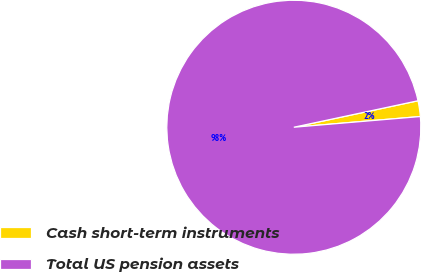Convert chart to OTSL. <chart><loc_0><loc_0><loc_500><loc_500><pie_chart><fcel>Cash short-term instruments<fcel>Total US pension assets<nl><fcel>2.0%<fcel>98.0%<nl></chart> 